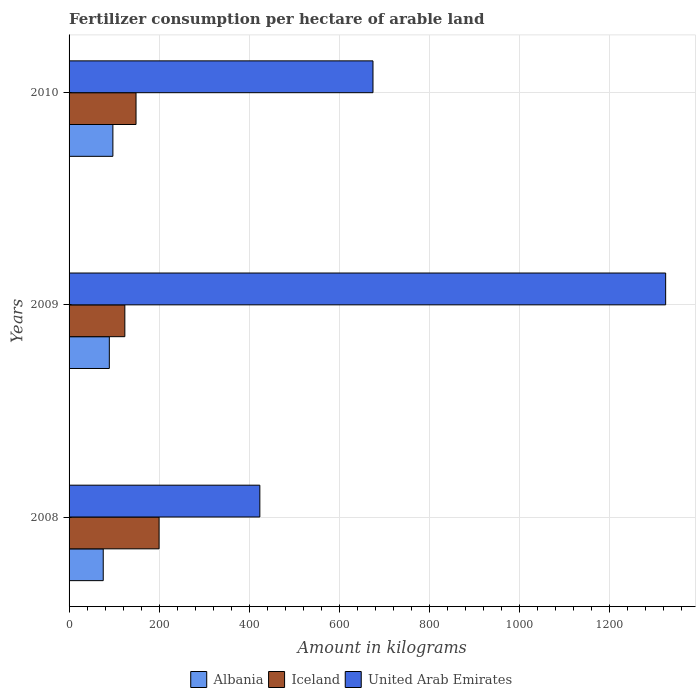Are the number of bars per tick equal to the number of legend labels?
Your answer should be compact. Yes. Are the number of bars on each tick of the Y-axis equal?
Ensure brevity in your answer.  Yes. How many bars are there on the 3rd tick from the bottom?
Provide a succinct answer. 3. What is the amount of fertilizer consumption in Iceland in 2010?
Your answer should be very brief. 148.7. Across all years, what is the maximum amount of fertilizer consumption in United Arab Emirates?
Provide a succinct answer. 1324.85. Across all years, what is the minimum amount of fertilizer consumption in United Arab Emirates?
Provide a succinct answer. 423.64. In which year was the amount of fertilizer consumption in Iceland maximum?
Offer a very short reply. 2008. In which year was the amount of fertilizer consumption in United Arab Emirates minimum?
Offer a very short reply. 2008. What is the total amount of fertilizer consumption in Albania in the graph?
Keep it short and to the point. 262.59. What is the difference between the amount of fertilizer consumption in United Arab Emirates in 2008 and that in 2010?
Offer a terse response. -251.26. What is the difference between the amount of fertilizer consumption in Iceland in 2010 and the amount of fertilizer consumption in Albania in 2009?
Your response must be concise. 59.31. What is the average amount of fertilizer consumption in Albania per year?
Provide a succinct answer. 87.53. In the year 2010, what is the difference between the amount of fertilizer consumption in United Arab Emirates and amount of fertilizer consumption in Iceland?
Give a very brief answer. 526.2. What is the ratio of the amount of fertilizer consumption in United Arab Emirates in 2008 to that in 2009?
Ensure brevity in your answer.  0.32. Is the amount of fertilizer consumption in United Arab Emirates in 2008 less than that in 2009?
Keep it short and to the point. Yes. Is the difference between the amount of fertilizer consumption in United Arab Emirates in 2009 and 2010 greater than the difference between the amount of fertilizer consumption in Iceland in 2009 and 2010?
Ensure brevity in your answer.  Yes. What is the difference between the highest and the second highest amount of fertilizer consumption in United Arab Emirates?
Provide a short and direct response. 649.95. What is the difference between the highest and the lowest amount of fertilizer consumption in United Arab Emirates?
Your answer should be very brief. 901.21. In how many years, is the amount of fertilizer consumption in Albania greater than the average amount of fertilizer consumption in Albania taken over all years?
Your answer should be very brief. 2. Is the sum of the amount of fertilizer consumption in Iceland in 2008 and 2009 greater than the maximum amount of fertilizer consumption in United Arab Emirates across all years?
Make the answer very short. No. What does the 2nd bar from the top in 2010 represents?
Offer a terse response. Iceland. What does the 2nd bar from the bottom in 2010 represents?
Make the answer very short. Iceland. Is it the case that in every year, the sum of the amount of fertilizer consumption in United Arab Emirates and amount of fertilizer consumption in Iceland is greater than the amount of fertilizer consumption in Albania?
Make the answer very short. Yes. How many bars are there?
Make the answer very short. 9. How many years are there in the graph?
Offer a terse response. 3. Does the graph contain any zero values?
Your answer should be compact. No. Does the graph contain grids?
Offer a terse response. Yes. Where does the legend appear in the graph?
Offer a terse response. Bottom center. How many legend labels are there?
Keep it short and to the point. 3. How are the legend labels stacked?
Your response must be concise. Horizontal. What is the title of the graph?
Keep it short and to the point. Fertilizer consumption per hectare of arable land. What is the label or title of the X-axis?
Provide a succinct answer. Amount in kilograms. What is the Amount in kilograms of Albania in 2008?
Provide a short and direct response. 75.88. What is the Amount in kilograms in Iceland in 2008?
Provide a short and direct response. 199.88. What is the Amount in kilograms in United Arab Emirates in 2008?
Ensure brevity in your answer.  423.64. What is the Amount in kilograms of Albania in 2009?
Keep it short and to the point. 89.39. What is the Amount in kilograms of Iceland in 2009?
Your response must be concise. 123.85. What is the Amount in kilograms in United Arab Emirates in 2009?
Make the answer very short. 1324.85. What is the Amount in kilograms in Albania in 2010?
Keep it short and to the point. 97.32. What is the Amount in kilograms in Iceland in 2010?
Your answer should be compact. 148.7. What is the Amount in kilograms of United Arab Emirates in 2010?
Ensure brevity in your answer.  674.9. Across all years, what is the maximum Amount in kilograms in Albania?
Keep it short and to the point. 97.32. Across all years, what is the maximum Amount in kilograms of Iceland?
Your answer should be very brief. 199.88. Across all years, what is the maximum Amount in kilograms in United Arab Emirates?
Ensure brevity in your answer.  1324.85. Across all years, what is the minimum Amount in kilograms of Albania?
Provide a succinct answer. 75.88. Across all years, what is the minimum Amount in kilograms in Iceland?
Provide a succinct answer. 123.85. Across all years, what is the minimum Amount in kilograms in United Arab Emirates?
Your response must be concise. 423.64. What is the total Amount in kilograms in Albania in the graph?
Your response must be concise. 262.59. What is the total Amount in kilograms of Iceland in the graph?
Keep it short and to the point. 472.43. What is the total Amount in kilograms in United Arab Emirates in the graph?
Provide a short and direct response. 2423.39. What is the difference between the Amount in kilograms of Albania in 2008 and that in 2009?
Offer a very short reply. -13.51. What is the difference between the Amount in kilograms in Iceland in 2008 and that in 2009?
Keep it short and to the point. 76.03. What is the difference between the Amount in kilograms in United Arab Emirates in 2008 and that in 2009?
Your answer should be compact. -901.21. What is the difference between the Amount in kilograms of Albania in 2008 and that in 2010?
Offer a terse response. -21.45. What is the difference between the Amount in kilograms of Iceland in 2008 and that in 2010?
Your response must be concise. 51.18. What is the difference between the Amount in kilograms in United Arab Emirates in 2008 and that in 2010?
Make the answer very short. -251.26. What is the difference between the Amount in kilograms of Albania in 2009 and that in 2010?
Ensure brevity in your answer.  -7.94. What is the difference between the Amount in kilograms in Iceland in 2009 and that in 2010?
Your response must be concise. -24.85. What is the difference between the Amount in kilograms of United Arab Emirates in 2009 and that in 2010?
Give a very brief answer. 649.95. What is the difference between the Amount in kilograms in Albania in 2008 and the Amount in kilograms in Iceland in 2009?
Keep it short and to the point. -47.97. What is the difference between the Amount in kilograms in Albania in 2008 and the Amount in kilograms in United Arab Emirates in 2009?
Your answer should be compact. -1248.97. What is the difference between the Amount in kilograms of Iceland in 2008 and the Amount in kilograms of United Arab Emirates in 2009?
Provide a short and direct response. -1124.97. What is the difference between the Amount in kilograms of Albania in 2008 and the Amount in kilograms of Iceland in 2010?
Offer a terse response. -72.82. What is the difference between the Amount in kilograms of Albania in 2008 and the Amount in kilograms of United Arab Emirates in 2010?
Provide a short and direct response. -599.02. What is the difference between the Amount in kilograms of Iceland in 2008 and the Amount in kilograms of United Arab Emirates in 2010?
Offer a very short reply. -475.02. What is the difference between the Amount in kilograms of Albania in 2009 and the Amount in kilograms of Iceland in 2010?
Your response must be concise. -59.31. What is the difference between the Amount in kilograms of Albania in 2009 and the Amount in kilograms of United Arab Emirates in 2010?
Ensure brevity in your answer.  -585.52. What is the difference between the Amount in kilograms in Iceland in 2009 and the Amount in kilograms in United Arab Emirates in 2010?
Ensure brevity in your answer.  -551.05. What is the average Amount in kilograms in Albania per year?
Give a very brief answer. 87.53. What is the average Amount in kilograms in Iceland per year?
Offer a very short reply. 157.48. What is the average Amount in kilograms in United Arab Emirates per year?
Your answer should be compact. 807.8. In the year 2008, what is the difference between the Amount in kilograms of Albania and Amount in kilograms of Iceland?
Ensure brevity in your answer.  -124. In the year 2008, what is the difference between the Amount in kilograms in Albania and Amount in kilograms in United Arab Emirates?
Your response must be concise. -347.77. In the year 2008, what is the difference between the Amount in kilograms of Iceland and Amount in kilograms of United Arab Emirates?
Offer a very short reply. -223.76. In the year 2009, what is the difference between the Amount in kilograms of Albania and Amount in kilograms of Iceland?
Provide a succinct answer. -34.46. In the year 2009, what is the difference between the Amount in kilograms of Albania and Amount in kilograms of United Arab Emirates?
Offer a very short reply. -1235.46. In the year 2009, what is the difference between the Amount in kilograms of Iceland and Amount in kilograms of United Arab Emirates?
Offer a terse response. -1201. In the year 2010, what is the difference between the Amount in kilograms in Albania and Amount in kilograms in Iceland?
Your answer should be very brief. -51.38. In the year 2010, what is the difference between the Amount in kilograms in Albania and Amount in kilograms in United Arab Emirates?
Provide a short and direct response. -577.58. In the year 2010, what is the difference between the Amount in kilograms in Iceland and Amount in kilograms in United Arab Emirates?
Offer a terse response. -526.2. What is the ratio of the Amount in kilograms of Albania in 2008 to that in 2009?
Make the answer very short. 0.85. What is the ratio of the Amount in kilograms of Iceland in 2008 to that in 2009?
Keep it short and to the point. 1.61. What is the ratio of the Amount in kilograms of United Arab Emirates in 2008 to that in 2009?
Keep it short and to the point. 0.32. What is the ratio of the Amount in kilograms in Albania in 2008 to that in 2010?
Your answer should be compact. 0.78. What is the ratio of the Amount in kilograms in Iceland in 2008 to that in 2010?
Your answer should be compact. 1.34. What is the ratio of the Amount in kilograms in United Arab Emirates in 2008 to that in 2010?
Provide a short and direct response. 0.63. What is the ratio of the Amount in kilograms of Albania in 2009 to that in 2010?
Your response must be concise. 0.92. What is the ratio of the Amount in kilograms of Iceland in 2009 to that in 2010?
Offer a terse response. 0.83. What is the ratio of the Amount in kilograms in United Arab Emirates in 2009 to that in 2010?
Offer a terse response. 1.96. What is the difference between the highest and the second highest Amount in kilograms in Albania?
Offer a very short reply. 7.94. What is the difference between the highest and the second highest Amount in kilograms of Iceland?
Your answer should be compact. 51.18. What is the difference between the highest and the second highest Amount in kilograms in United Arab Emirates?
Your answer should be compact. 649.95. What is the difference between the highest and the lowest Amount in kilograms of Albania?
Offer a very short reply. 21.45. What is the difference between the highest and the lowest Amount in kilograms of Iceland?
Provide a succinct answer. 76.03. What is the difference between the highest and the lowest Amount in kilograms of United Arab Emirates?
Make the answer very short. 901.21. 